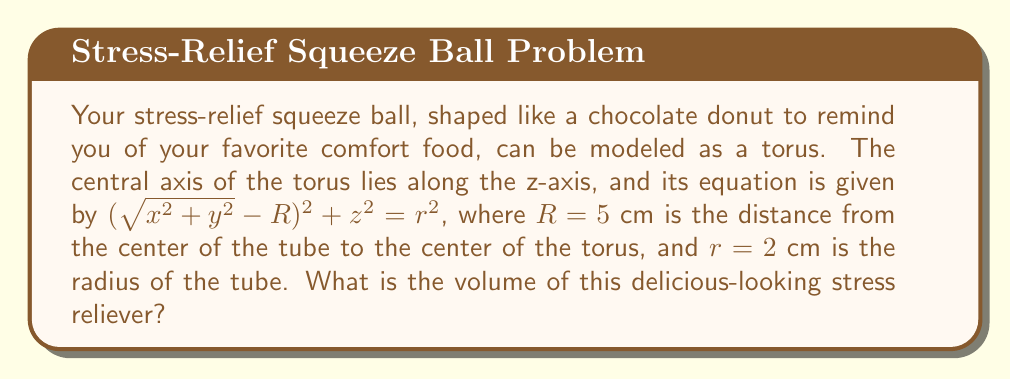Show me your answer to this math problem. Let's approach this step-by-step:

1) The volume of a torus is given by the formula:

   $$V = 2\pi^2 R r^2$$

   Where $R$ is the distance from the center of the tube to the center of the torus, and $r$ is the radius of the tube.

2) We are given:
   $R = 5$ cm
   $r = 2$ cm

3) Let's substitute these values into the formula:

   $$V = 2\pi^2 (5) (2^2)$$

4) Simplify:
   $$V = 2\pi^2 (5) (4)$$
   $$V = 40\pi^2$$

5) Calculate the final value:
   $$V \approx 394.78 \text{ cm}^3$$

Therefore, the volume of your donut-shaped stress-relief squeeze ball is approximately 394.78 cubic centimeters.
Answer: $394.78 \text{ cm}^3$ 